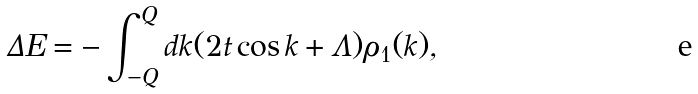Convert formula to latex. <formula><loc_0><loc_0><loc_500><loc_500>\Delta E = - \int _ { - Q } ^ { Q } d k ( 2 t \cos k + \Lambda ) \rho _ { 1 } ( k ) ,</formula> 